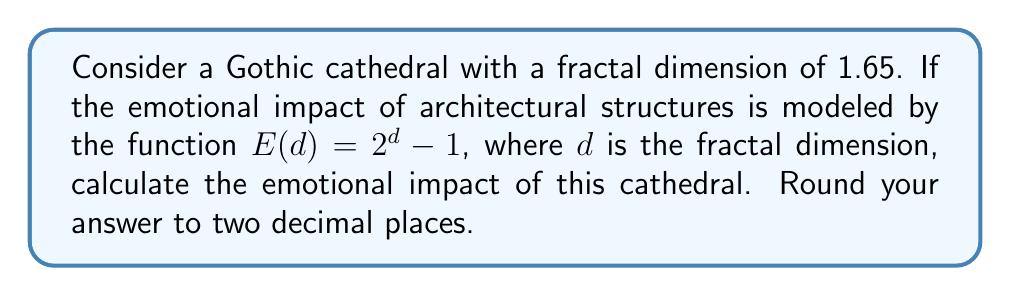Could you help me with this problem? To solve this problem, we'll follow these steps:

1) We are given that the fractal dimension $d$ of the Gothic cathedral is 1.65.

2) The emotional impact $E$ is modeled by the function:

   $E(d) = 2^d - 1$

3) We need to substitute $d = 1.65$ into this function:

   $E(1.65) = 2^{1.65} - 1$

4) To calculate this:
   
   a) First, let's compute $2^{1.65}$:
      $2^{1.65} \approx 3.1352...$ (using a calculator)
   
   b) Now, subtract 1:
      $3.1352... - 1 = 2.1352...$

5) Rounding to two decimal places:

   $2.1352... \approx 2.14$

Thus, the emotional impact of the Gothic cathedral with a fractal dimension of 1.65 is approximately 2.14 units on this scale.
Answer: 2.14 